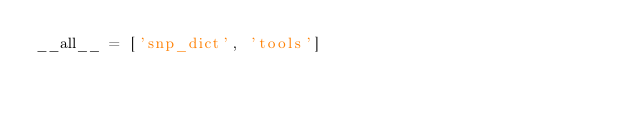Convert code to text. <code><loc_0><loc_0><loc_500><loc_500><_Python_>__all__ = ['snp_dict', 'tools']
</code> 